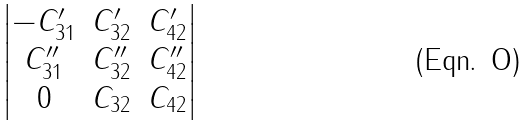Convert formula to latex. <formula><loc_0><loc_0><loc_500><loc_500>\begin{vmatrix} - C ^ { \prime } _ { 3 1 } & C ^ { \prime } _ { 3 2 } & C ^ { \prime } _ { 4 2 } \\ C ^ { \prime \prime } _ { 3 1 } & C ^ { \prime \prime } _ { 3 2 } & C ^ { \prime \prime } _ { 4 2 } \\ 0 & C _ { 3 2 } & C _ { 4 2 } \end{vmatrix}</formula> 